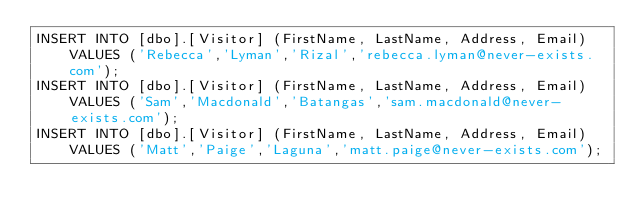<code> <loc_0><loc_0><loc_500><loc_500><_SQL_>INSERT INTO [dbo].[Visitor] (FirstName, LastName, Address, Email) VALUES ('Rebecca','Lyman','Rizal','rebecca.lyman@never-exists.com');
INSERT INTO [dbo].[Visitor] (FirstName, LastName, Address, Email) VALUES ('Sam','Macdonald','Batangas','sam.macdonald@never-exists.com');
INSERT INTO [dbo].[Visitor] (FirstName, LastName, Address, Email) VALUES ('Matt','Paige','Laguna','matt.paige@never-exists.com');
</code> 